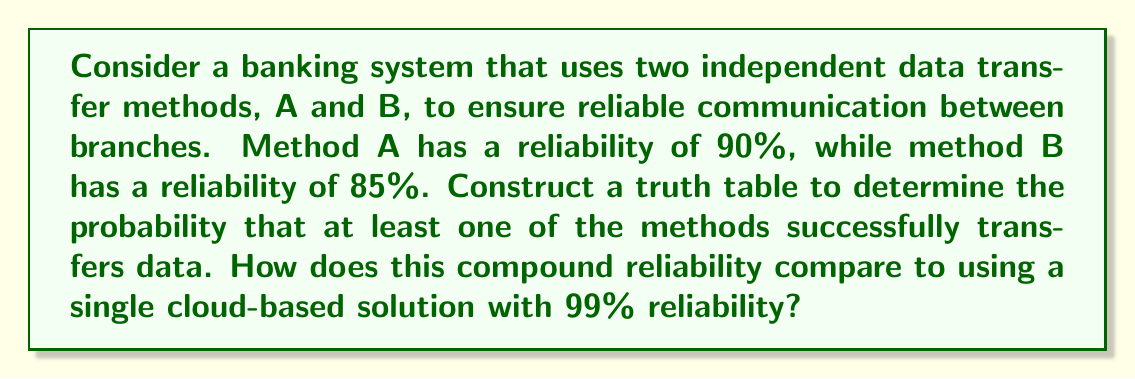Show me your answer to this math problem. Let's approach this step-by-step:

1) First, we need to construct a truth table for the given scenario. Let's define:
   A: Method A succeeds (90% probability)
   B: Method B succeeds (85% probability)

   The truth table will look like this:

   | A | B | A OR B |
   |---|---|--------|
   | T | T |   T    |
   | T | F |   T    |
   | F | T |   T    |
   | F | F |   F    |

2) Now, let's calculate the probabilities:
   P(A) = 0.90
   P(B) = 0.85

3) The probability of at least one method succeeding is the opposite of both failing:

   $$P(\text{at least one succeeds}) = 1 - P(\text{both fail})$$
   $$= 1 - (1-P(A))(1-P(B))$$
   $$= 1 - (0.1)(0.15)$$
   $$= 1 - 0.015$$
   $$= 0.985$$

4) Converting to a percentage:
   0.985 * 100 = 98.5%

5) Comparing to the cloud-based solution:
   Traditional system reliability: 98.5%
   Cloud-based solution reliability: 99%

   The difference is:
   $$99\% - 98.5\% = 0.5\%$$
Answer: The probability that at least one of the traditional methods successfully transfers data is 98.5%. This is 0.5% less reliable than the single cloud-based solution with 99% reliability. 